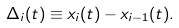<formula> <loc_0><loc_0><loc_500><loc_500>\Delta _ { i } ( t ) \equiv x _ { i } ( t ) - x _ { i - 1 } ( t ) .</formula> 